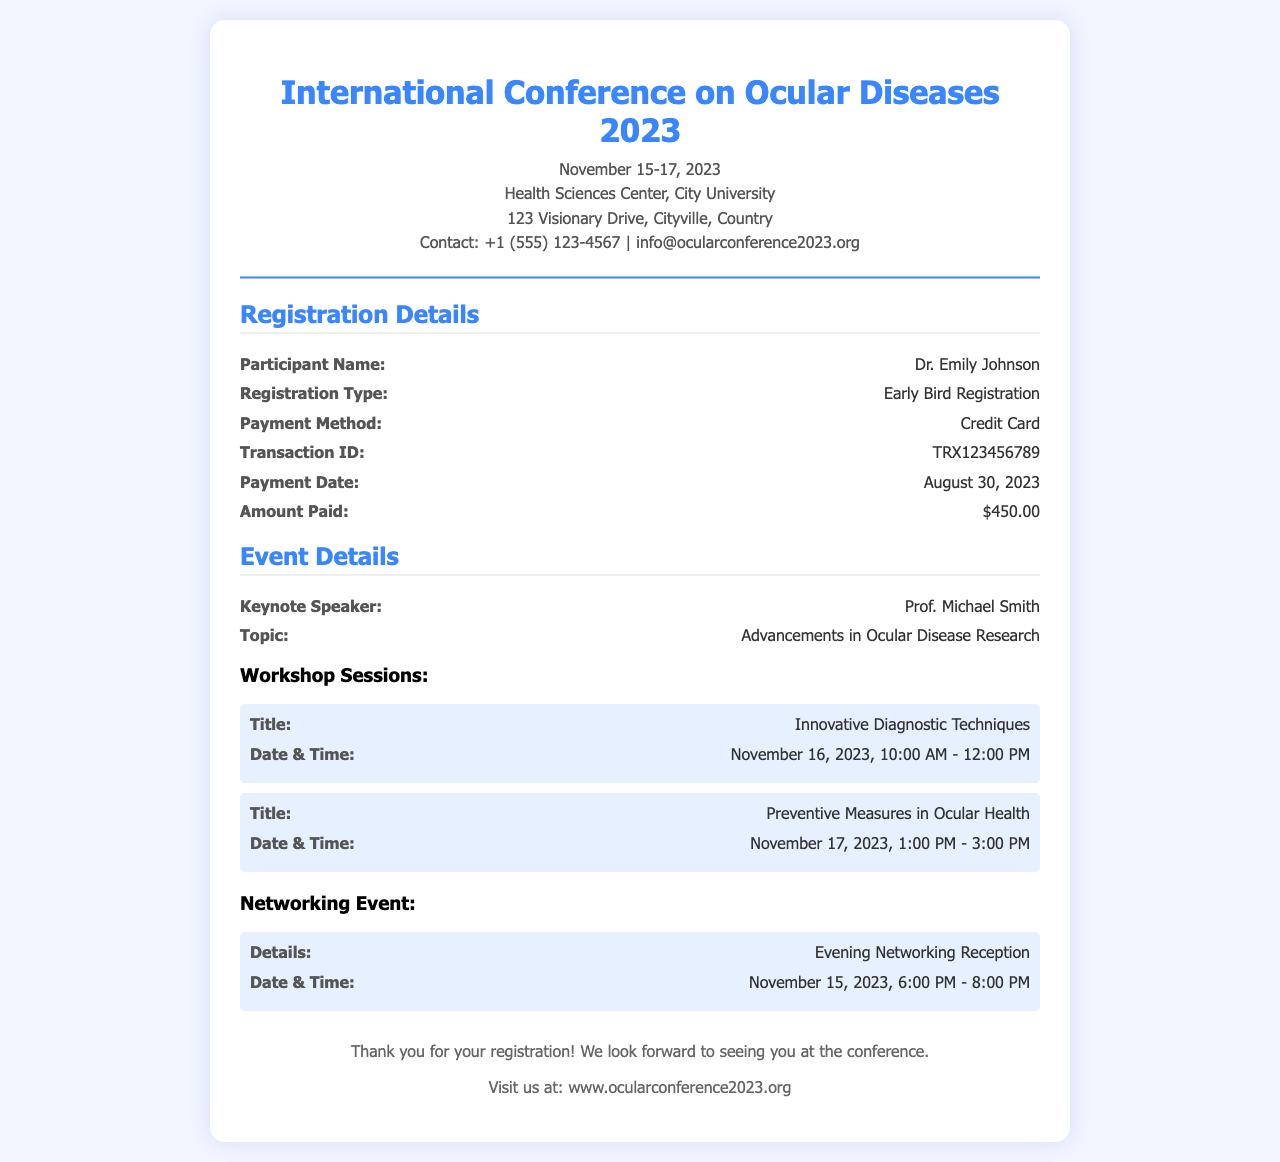What is the name of the conference? The name of the conference is explicitly mentioned in the header section of the document.
Answer: International Conference on Ocular Diseases 2023 What are the dates of the conference? The conference dates are provided right after the conference name in the header section.
Answer: November 15-17, 2023 Who is the participant? The document specifies the participant’s name in the registration details section.
Answer: Dr. Emily Johnson What is the amount paid for registration? The registration fee is clearly indicated in the registration details section of the document.
Answer: $450.00 What is the payment method used? This information is included under the registration details, indicating how the payment was made.
Answer: Credit Card What is the transaction ID? The transaction ID is provided in the registration details, verifying the payment confirmation.
Answer: TRX123456789 What is the title of the keynote speech? This title is found under the event details section of the document, summarizing key topics.
Answer: Advancements in Ocular Disease Research What are the dates and times of the first workshop session? The dates and times are detailed in the workshop sessions subsection under event details.
Answer: November 16, 2023, 10:00 AM - 12:00 PM What networking event is mentioned? The details about the networking event are provided in the event details section, emphasizing the nature of the gathering.
Answer: Evening Networking Reception 